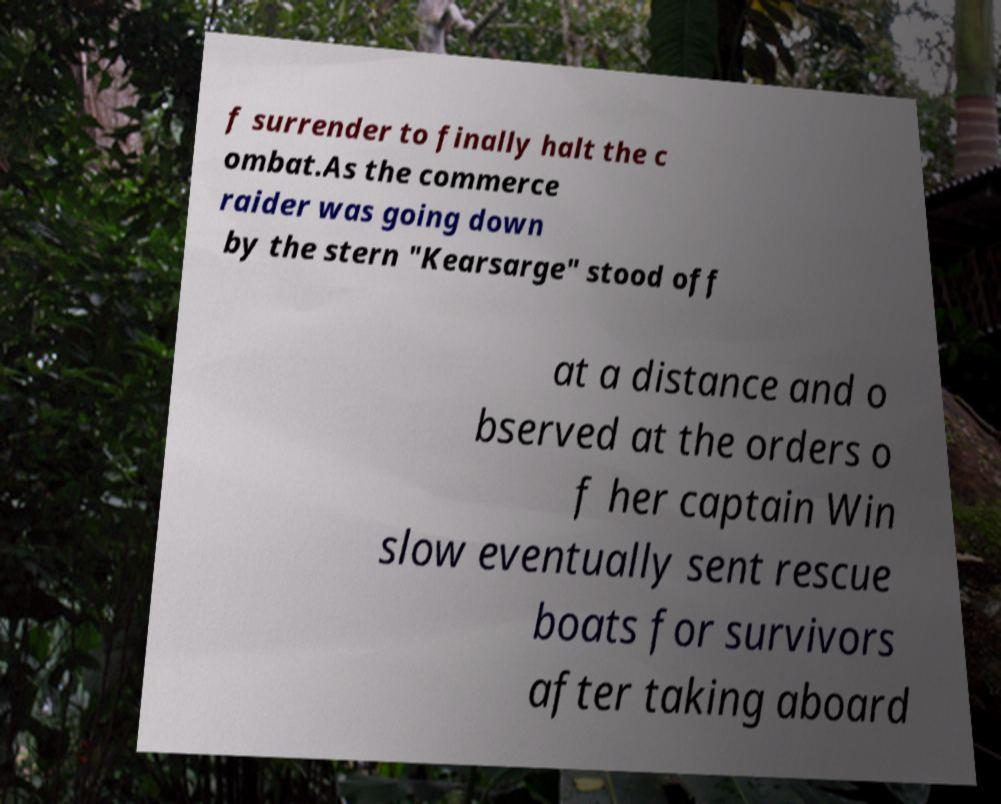For documentation purposes, I need the text within this image transcribed. Could you provide that? f surrender to finally halt the c ombat.As the commerce raider was going down by the stern "Kearsarge" stood off at a distance and o bserved at the orders o f her captain Win slow eventually sent rescue boats for survivors after taking aboard 